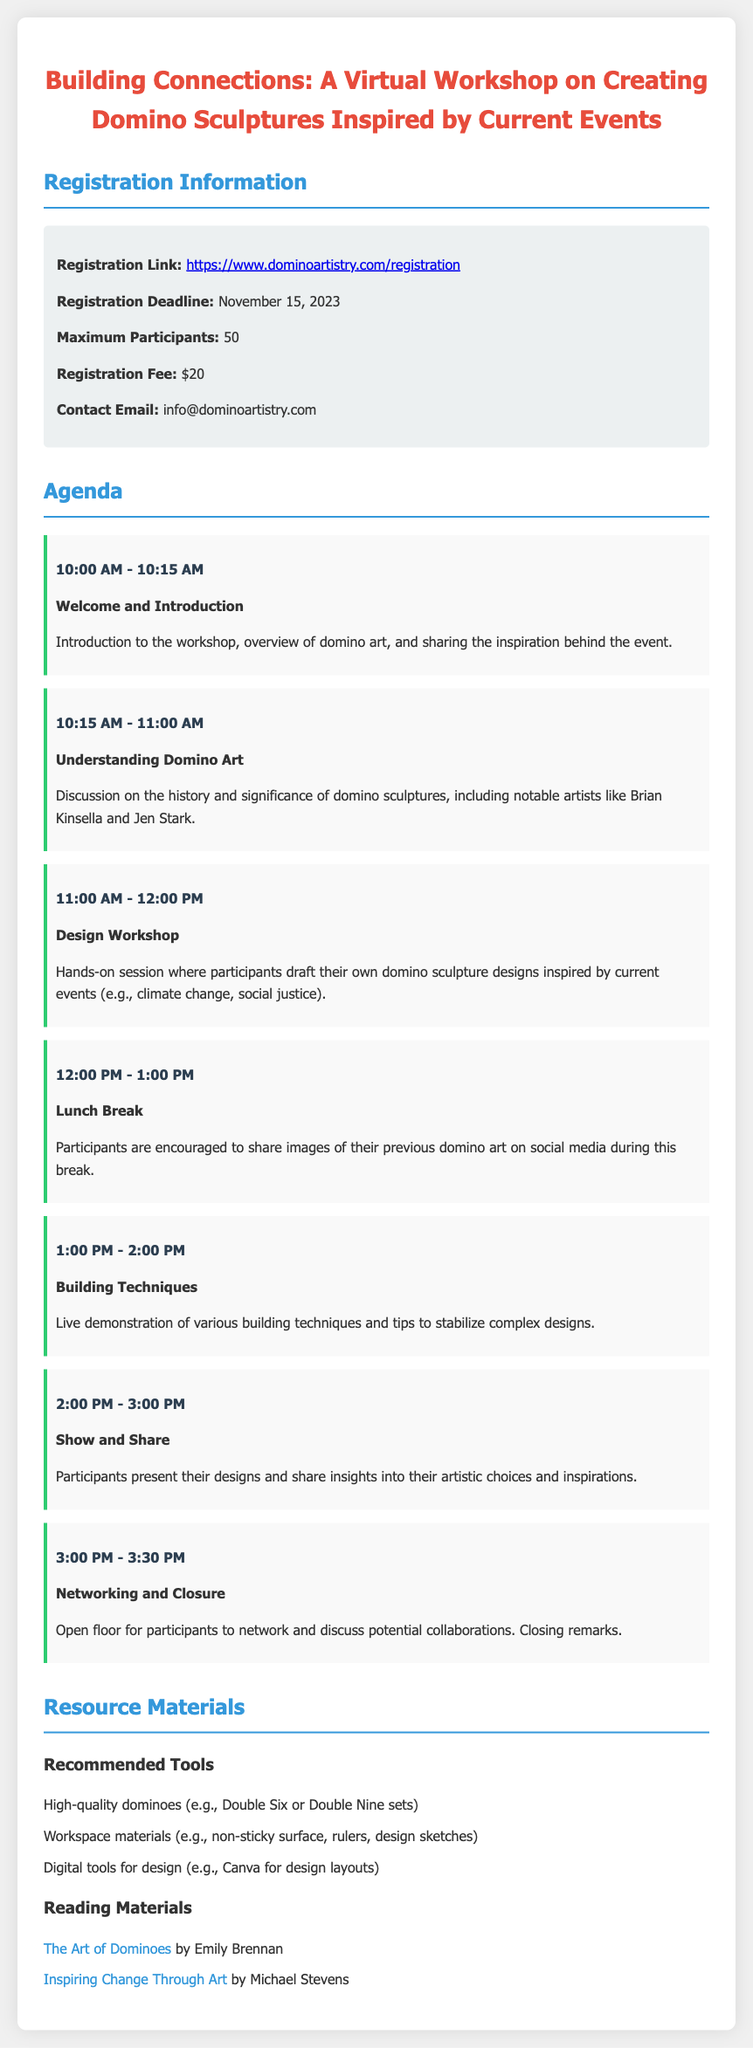what is the registration link? The registration link is where participants can sign up for the workshop, as stated in the document.
Answer: https://www.dominoartistry.com/registration what is the maximum number of participants? The document specifies the limit on how many participants can join the workshop.
Answer: 50 when is the registration deadline? The registration deadline is mentioned in the document, indicating the last date participants can sign up.
Answer: November 15, 2023 what is the fee to register for the workshop? The registration fee is clearly stated in the document, indicating how much needs to be paid to participate.
Answer: $20 what time does the "Design Workshop" start? The start time for the "Design Workshop" session is included in the agenda section of the document.
Answer: 11:00 AM which two artists are mentioned in the agenda? The document lists notable artists in the Understanding Domino Art section, highlighting influential figures in domino sculpture.
Answer: Brian Kinsella and Jen Stark what is the purpose of the "Show and Share" session? The document describes the objectives of the "Show and Share" session, focusing on participant engagement.
Answer: Participants present their designs and share insights into their artistic choices and inspirations what type of materials are recommended for workspace? The document lists specific materials that participants should prepare for their workspace during the workshop.
Answer: non-sticky surface, rulers, design sketches what is the title of the reading material by Michael Stevens? The document lists reading materials with their respective authors, specifying their contributions to the workshop's theme.
Answer: Inspiring Change Through Art 